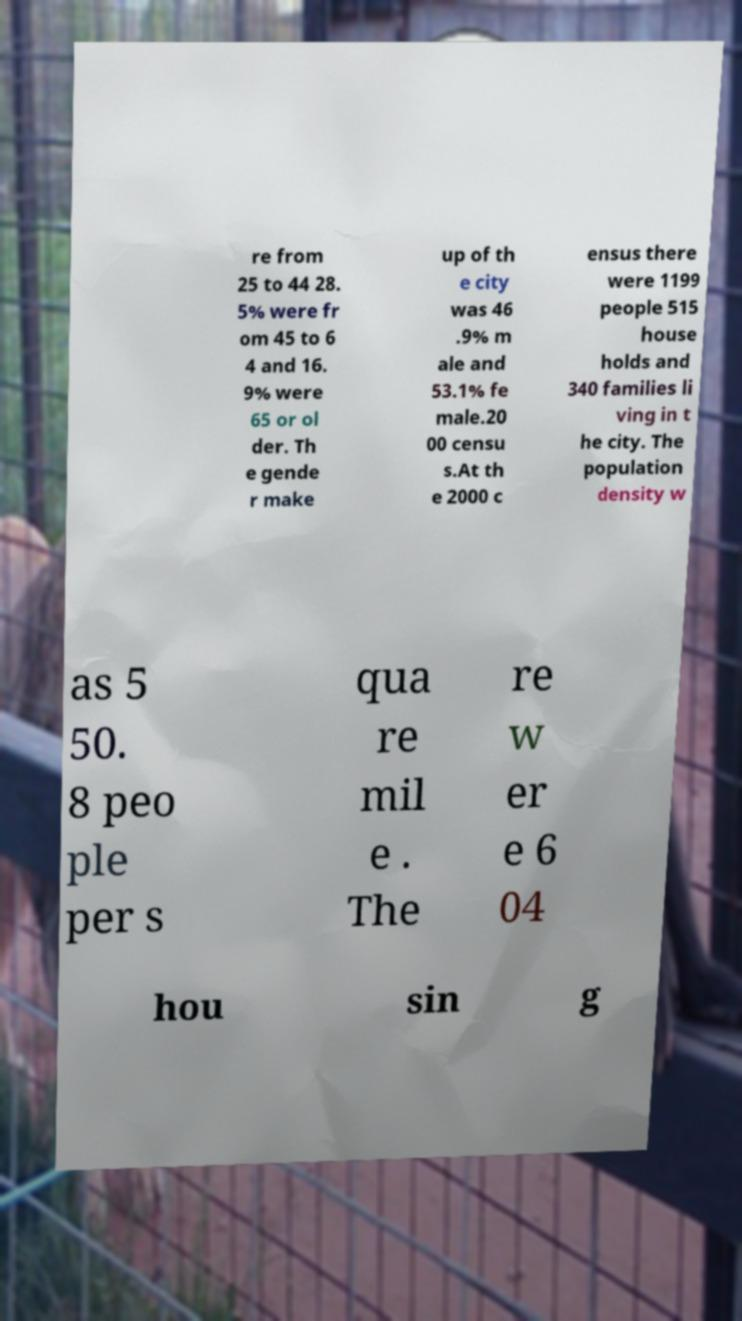Could you assist in decoding the text presented in this image and type it out clearly? re from 25 to 44 28. 5% were fr om 45 to 6 4 and 16. 9% were 65 or ol der. Th e gende r make up of th e city was 46 .9% m ale and 53.1% fe male.20 00 censu s.At th e 2000 c ensus there were 1199 people 515 house holds and 340 families li ving in t he city. The population density w as 5 50. 8 peo ple per s qua re mil e . The re w er e 6 04 hou sin g 